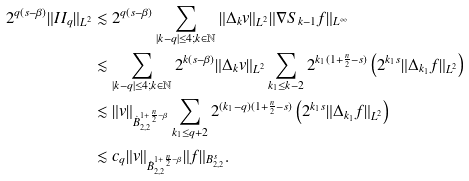Convert formula to latex. <formula><loc_0><loc_0><loc_500><loc_500>2 ^ { q ( s - \beta ) } \| I I _ { q } \| _ { L ^ { 2 } } & \lesssim 2 ^ { q ( s - \beta ) } \sum _ { | k - q | \leq 4 ; k \in \mathbb { N } } \| \Delta _ { k } v \| _ { L ^ { 2 } } \| \nabla S _ { k - 1 } f \| _ { L ^ { \infty } } \\ & \lesssim \sum _ { | k - q | \leq 4 ; k \in \mathbb { N } } 2 ^ { k ( s - \beta ) } \| \Delta _ { k } v \| _ { L ^ { 2 } } \sum _ { k _ { 1 } \leq k - 2 } 2 ^ { k _ { 1 } ( 1 + \frac { n } { 2 } - s ) } \left ( 2 ^ { k _ { 1 } s } \| \Delta _ { k _ { 1 } } f \| _ { L ^ { 2 } } \right ) \\ & \lesssim \| v \| _ { \dot { B } _ { 2 , 2 } ^ { 1 + \frac { n } { 2 } - \beta } } \sum _ { k _ { 1 } \leq q + 2 } 2 ^ { ( k _ { 1 } - q ) ( 1 + \frac { n } { 2 } - s ) } \left ( 2 ^ { k _ { 1 } s } \| \Delta _ { k _ { 1 } } f \| _ { L ^ { 2 } } \right ) \\ & \lesssim c _ { q } \| v \| _ { \dot { B } _ { 2 , 2 } ^ { 1 + \frac { n } { 2 } - \beta } } \| f \| _ { B _ { 2 , 2 } ^ { s } } .</formula> 